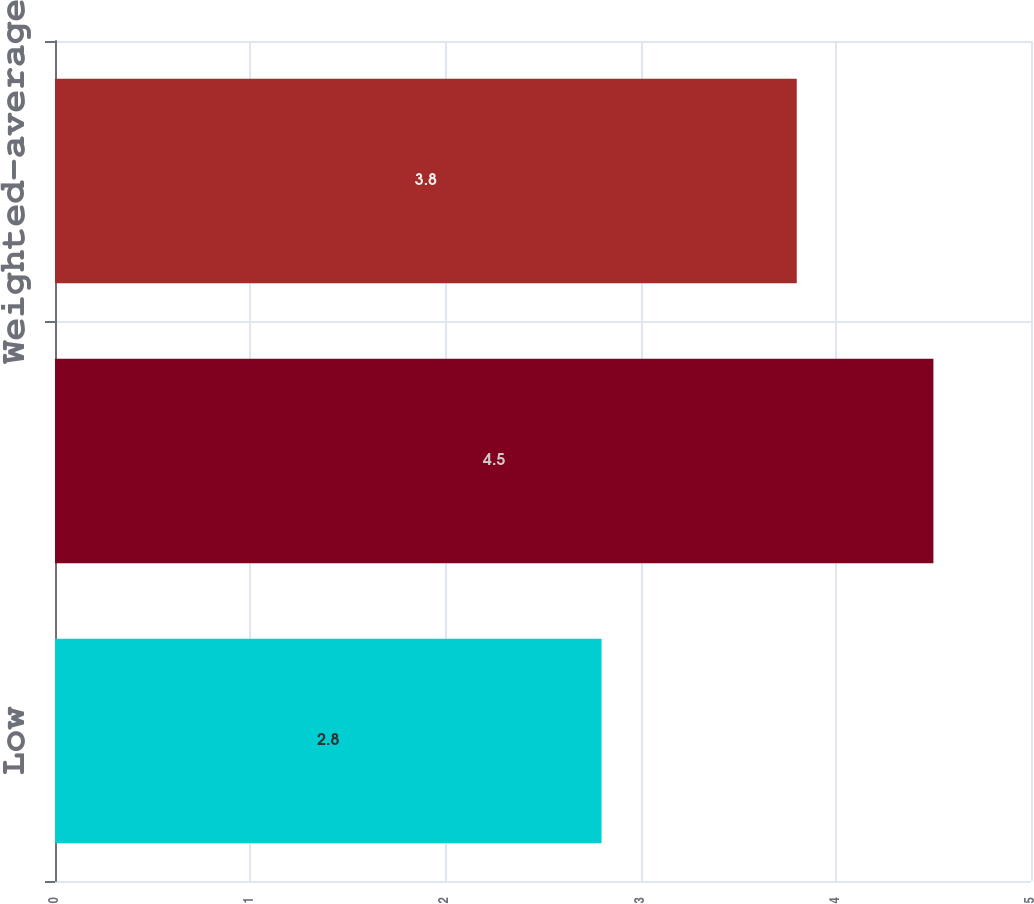Convert chart to OTSL. <chart><loc_0><loc_0><loc_500><loc_500><bar_chart><fcel>Low<fcel>High<fcel>Weighted-average<nl><fcel>2.8<fcel>4.5<fcel>3.8<nl></chart> 